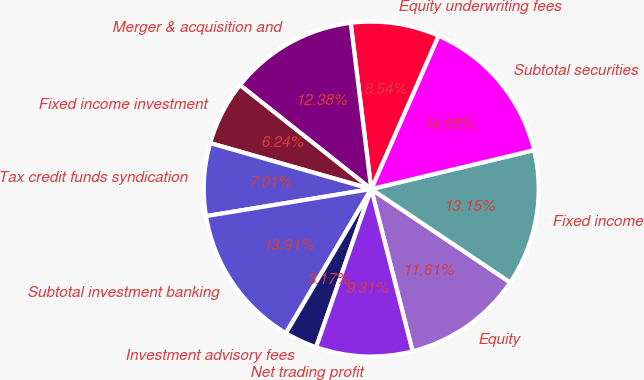Convert chart. <chart><loc_0><loc_0><loc_500><loc_500><pie_chart><fcel>Equity<fcel>Fixed income<fcel>Subtotal securities<fcel>Equity underwriting fees<fcel>Merger & acquisition and<fcel>Fixed income investment<fcel>Tax credit funds syndication<fcel>Subtotal investment banking<fcel>Investment advisory fees<fcel>Net trading profit<nl><fcel>11.61%<fcel>13.15%<fcel>14.68%<fcel>8.54%<fcel>12.38%<fcel>6.24%<fcel>7.01%<fcel>13.91%<fcel>3.17%<fcel>9.31%<nl></chart> 